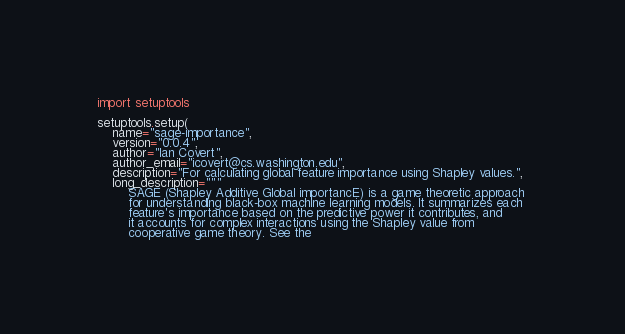Convert code to text. <code><loc_0><loc_0><loc_500><loc_500><_Python_>import setuptools

setuptools.setup(
    name="sage-importance",
    version="0.0.4",
    author="Ian Covert",
    author_email="icovert@cs.washington.edu",
    description="For calculating global feature importance using Shapley values.",
    long_description="""
        SAGE (Shapley Additive Global importancE) is a game theoretic approach 
        for understanding black-box machine learning models. It summarizes each 
        feature's importance based on the predictive power it contributes, and 
        it accounts for complex interactions using the Shapley value from 
        cooperative game theory. See the </code> 